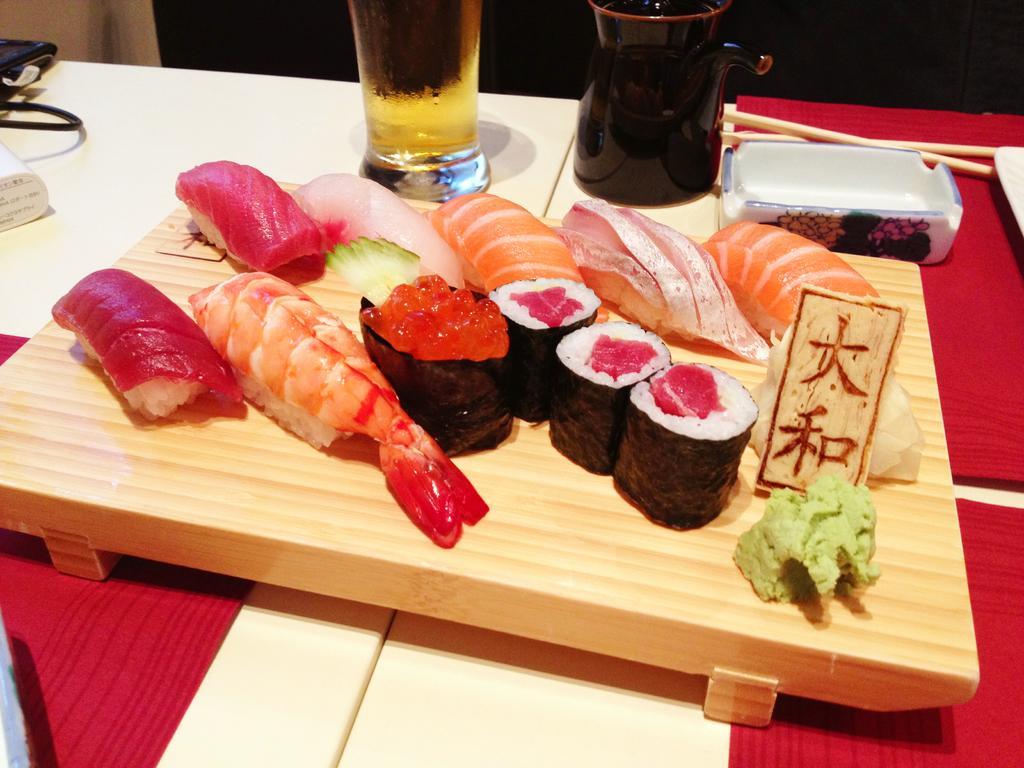Can you describe this image briefly? In this image at the bottom there is a table, on the table there is one board. On the board there is some meat and on the table there is a glass, cup, box, chopsticks and some other objects. 